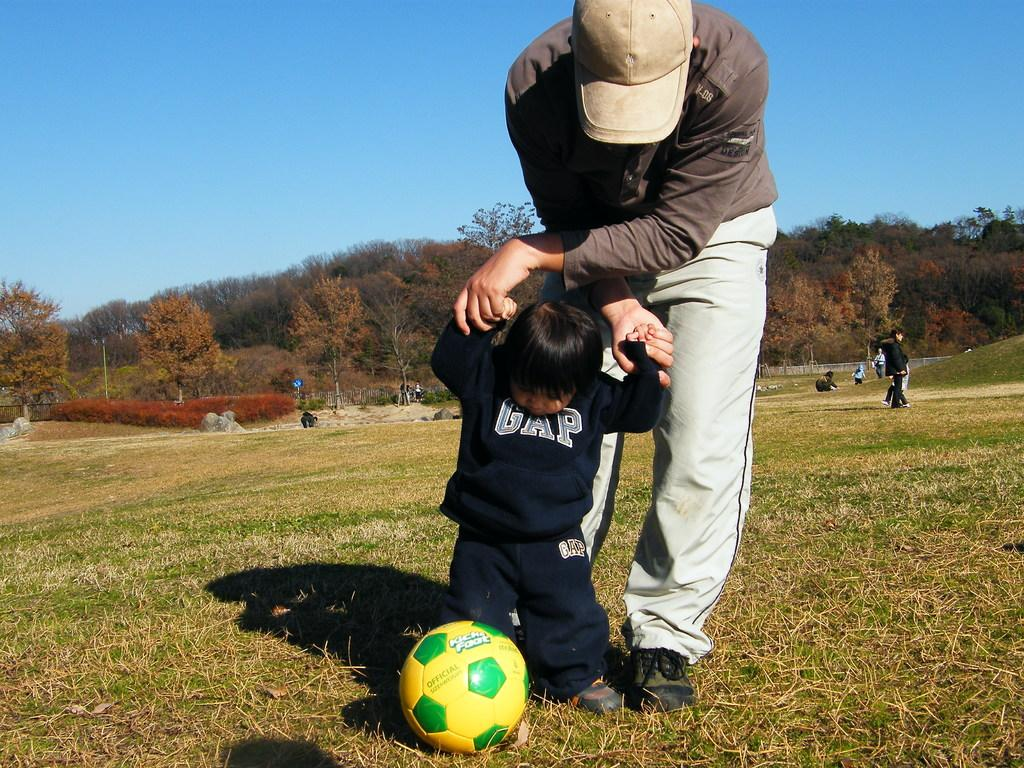Who are the main subjects in the image? There is a person and a kid in the center of the image. What are they holding? They are holding a football. What can be seen in the background of the image? There are trees, other persons, a wall, grass, and the sky visible in the background of the image. Where can the nest of the bird be seen in the image? There is no nest visible in the image. What type of salt is being used to season the football in the image? There is no salt present in the image, and the football is not being seasoned. 